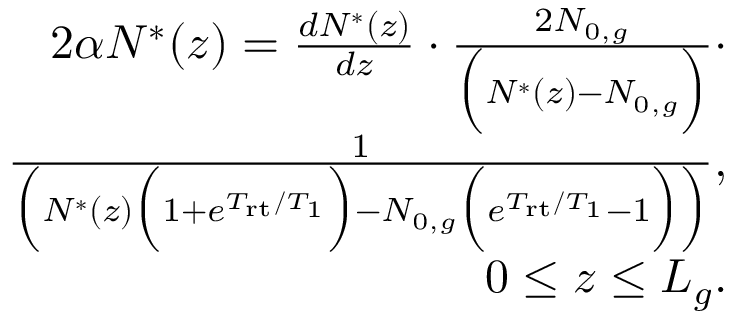Convert formula to latex. <formula><loc_0><loc_0><loc_500><loc_500>\begin{array} { r l r } & { 2 \alpha N ^ { * } ( z ) = \frac { d N ^ { * } ( z ) } { d z } \cdot \frac { 2 N _ { 0 , g } } { \left ( N ^ { * } ( z ) - N _ { 0 , g } \right ) } \cdot } \\ & { \frac { 1 } { \left ( N ^ { * } ( z ) \left ( 1 + e ^ { T _ { r t } / T _ { 1 } } \right ) - N _ { 0 , g } \left ( e ^ { T _ { r t } / T _ { 1 } } - 1 \right ) \right ) } , } \\ & { 0 \leq z \leq L _ { g } . } \end{array}</formula> 